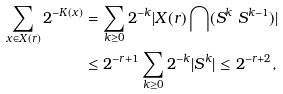<formula> <loc_0><loc_0><loc_500><loc_500>\sum _ { x \in X ( r ) } 2 ^ { - K ( x ) } & = \sum _ { k \geq 0 } 2 ^ { - k } | X ( r ) \bigcap ( S ^ { k } \ S ^ { k - 1 } ) | \\ & \leq 2 ^ { - r + 1 } \sum _ { k \geq 0 } 2 ^ { - k } | S ^ { k } | \leq 2 ^ { - r + 2 } ,</formula> 